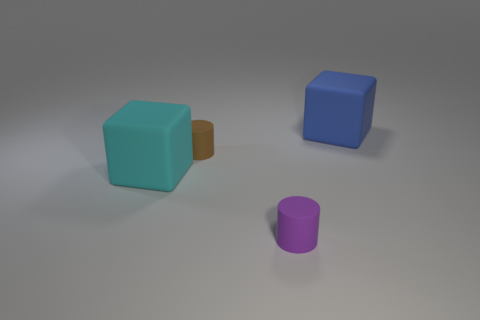Is the purple thing the same size as the brown object?
Offer a terse response. Yes. Is there a tiny purple rubber cylinder?
Make the answer very short. Yes. Is there anything else that is the same material as the brown cylinder?
Provide a succinct answer. Yes. Is there another object that has the same material as the cyan object?
Your answer should be compact. Yes. There is a brown cylinder that is the same size as the purple cylinder; what material is it?
Offer a very short reply. Rubber. How many big cyan things are the same shape as the small purple object?
Your response must be concise. 0. What is the size of the blue block that is the same material as the large cyan block?
Provide a succinct answer. Large. There is a thing that is in front of the brown matte object and right of the cyan rubber thing; what material is it?
Make the answer very short. Rubber. What number of purple objects are the same size as the purple cylinder?
Make the answer very short. 0. There is a big cyan object that is the same shape as the large blue thing; what is it made of?
Make the answer very short. Rubber. 